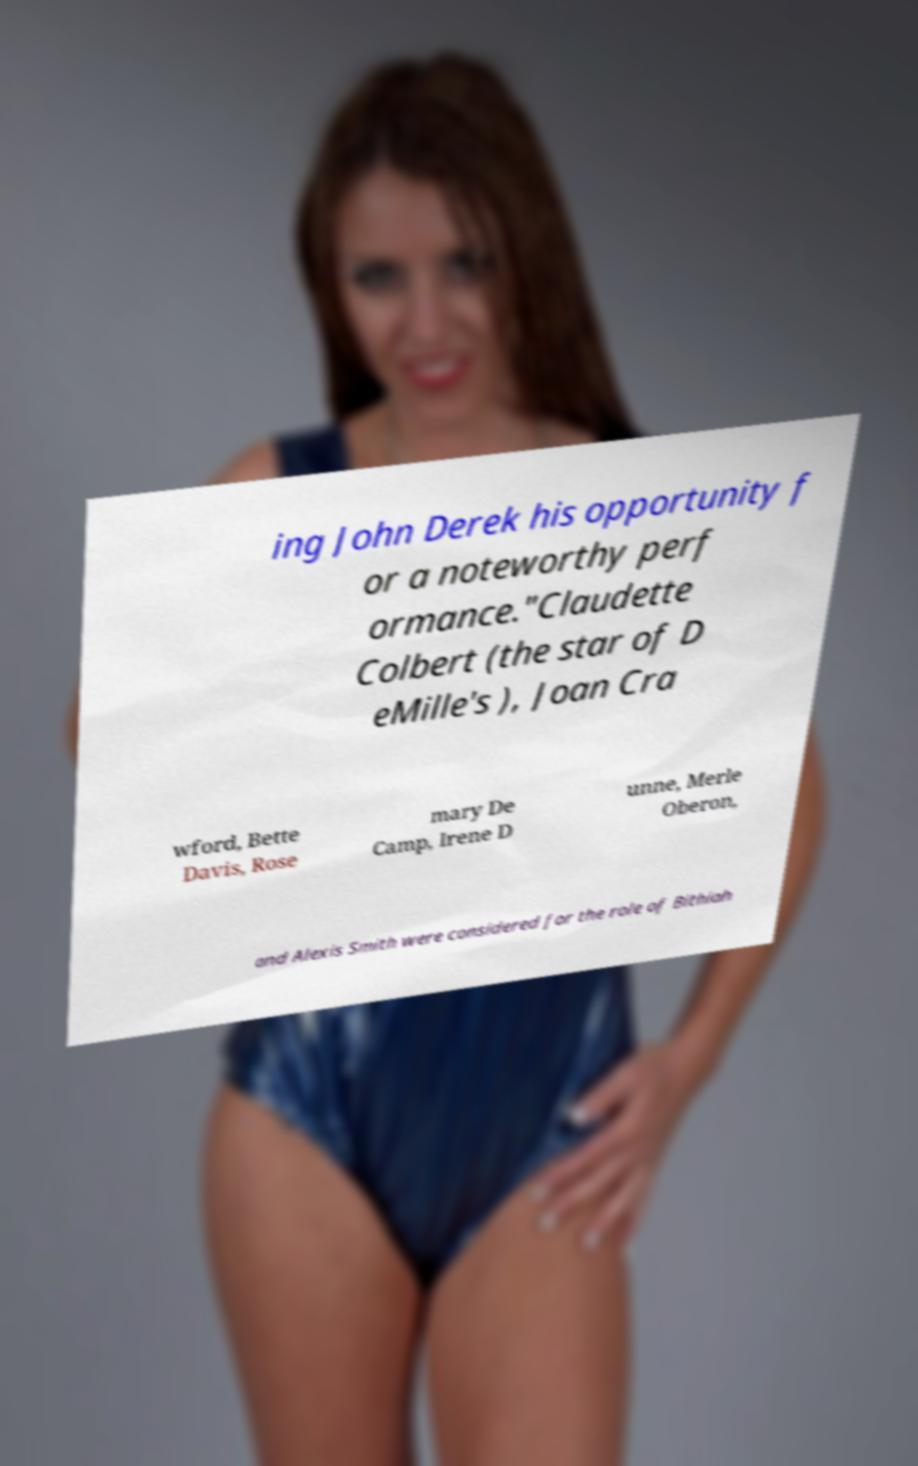Could you assist in decoding the text presented in this image and type it out clearly? ing John Derek his opportunity f or a noteworthy perf ormance."Claudette Colbert (the star of D eMille's ), Joan Cra wford, Bette Davis, Rose mary De Camp, Irene D unne, Merle Oberon, and Alexis Smith were considered for the role of Bithiah 